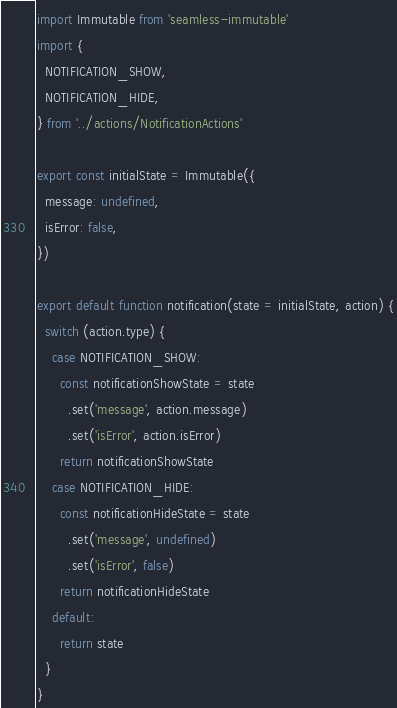Convert code to text. <code><loc_0><loc_0><loc_500><loc_500><_JavaScript_>import Immutable from 'seamless-immutable'
import {
  NOTIFICATION_SHOW,
  NOTIFICATION_HIDE,
} from '../actions/NotificationActions'

export const initialState = Immutable({
  message: undefined,
  isError: false,
})

export default function notification(state = initialState, action) {
  switch (action.type) {
    case NOTIFICATION_SHOW:
      const notificationShowState = state
        .set('message', action.message)
        .set('isError', action.isError)
      return notificationShowState
    case NOTIFICATION_HIDE:
      const notificationHideState = state
        .set('message', undefined)
        .set('isError', false)
      return notificationHideState
    default:
      return state
  }
}
</code> 